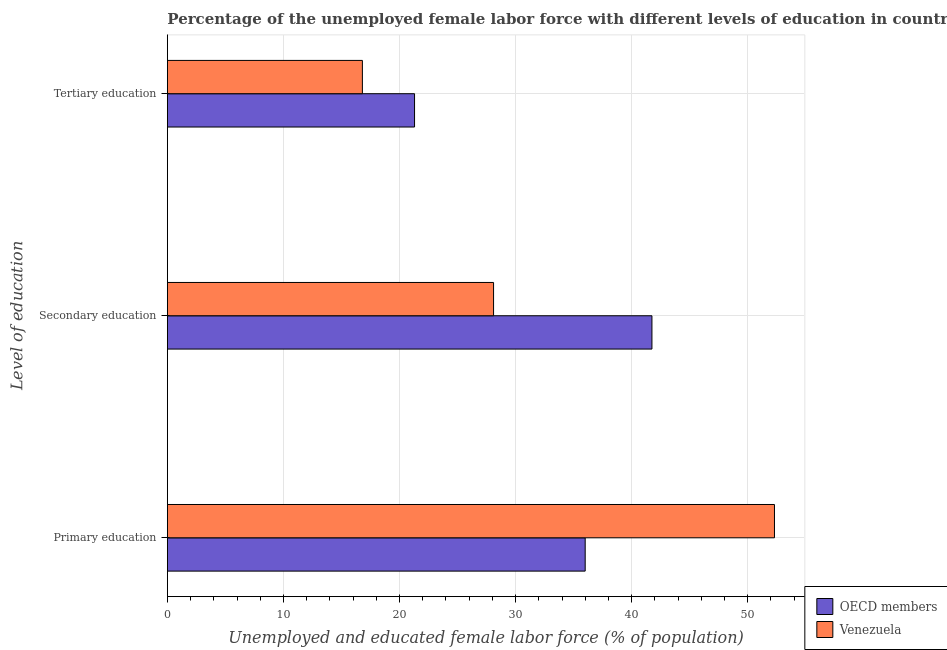How many different coloured bars are there?
Your answer should be very brief. 2. How many groups of bars are there?
Provide a short and direct response. 3. Are the number of bars per tick equal to the number of legend labels?
Ensure brevity in your answer.  Yes. What is the label of the 2nd group of bars from the top?
Provide a succinct answer. Secondary education. What is the percentage of female labor force who received secondary education in Venezuela?
Provide a succinct answer. 28.1. Across all countries, what is the maximum percentage of female labor force who received tertiary education?
Provide a short and direct response. 21.29. Across all countries, what is the minimum percentage of female labor force who received tertiary education?
Your answer should be very brief. 16.8. In which country was the percentage of female labor force who received primary education maximum?
Provide a short and direct response. Venezuela. In which country was the percentage of female labor force who received secondary education minimum?
Give a very brief answer. Venezuela. What is the total percentage of female labor force who received primary education in the graph?
Offer a very short reply. 88.29. What is the difference between the percentage of female labor force who received secondary education in OECD members and that in Venezuela?
Provide a succinct answer. 13.64. What is the difference between the percentage of female labor force who received secondary education in OECD members and the percentage of female labor force who received tertiary education in Venezuela?
Your answer should be compact. 24.94. What is the average percentage of female labor force who received tertiary education per country?
Provide a short and direct response. 19.05. What is the difference between the percentage of female labor force who received secondary education and percentage of female labor force who received tertiary education in OECD members?
Offer a very short reply. 20.45. In how many countries, is the percentage of female labor force who received primary education greater than 34 %?
Offer a terse response. 2. What is the ratio of the percentage of female labor force who received primary education in Venezuela to that in OECD members?
Ensure brevity in your answer.  1.45. Is the difference between the percentage of female labor force who received primary education in OECD members and Venezuela greater than the difference between the percentage of female labor force who received tertiary education in OECD members and Venezuela?
Ensure brevity in your answer.  No. What is the difference between the highest and the second highest percentage of female labor force who received tertiary education?
Your response must be concise. 4.49. What is the difference between the highest and the lowest percentage of female labor force who received primary education?
Keep it short and to the point. 16.31. What does the 1st bar from the top in Primary education represents?
Your answer should be very brief. Venezuela. What does the 2nd bar from the bottom in Tertiary education represents?
Provide a succinct answer. Venezuela. Are all the bars in the graph horizontal?
Make the answer very short. Yes. How many countries are there in the graph?
Offer a terse response. 2. What is the difference between two consecutive major ticks on the X-axis?
Keep it short and to the point. 10. Are the values on the major ticks of X-axis written in scientific E-notation?
Make the answer very short. No. What is the title of the graph?
Your answer should be very brief. Percentage of the unemployed female labor force with different levels of education in countries. Does "South Sudan" appear as one of the legend labels in the graph?
Keep it short and to the point. No. What is the label or title of the X-axis?
Your answer should be very brief. Unemployed and educated female labor force (% of population). What is the label or title of the Y-axis?
Ensure brevity in your answer.  Level of education. What is the Unemployed and educated female labor force (% of population) in OECD members in Primary education?
Offer a terse response. 35.99. What is the Unemployed and educated female labor force (% of population) in Venezuela in Primary education?
Keep it short and to the point. 52.3. What is the Unemployed and educated female labor force (% of population) of OECD members in Secondary education?
Offer a terse response. 41.74. What is the Unemployed and educated female labor force (% of population) in Venezuela in Secondary education?
Make the answer very short. 28.1. What is the Unemployed and educated female labor force (% of population) in OECD members in Tertiary education?
Provide a succinct answer. 21.29. What is the Unemployed and educated female labor force (% of population) of Venezuela in Tertiary education?
Make the answer very short. 16.8. Across all Level of education, what is the maximum Unemployed and educated female labor force (% of population) in OECD members?
Your response must be concise. 41.74. Across all Level of education, what is the maximum Unemployed and educated female labor force (% of population) in Venezuela?
Make the answer very short. 52.3. Across all Level of education, what is the minimum Unemployed and educated female labor force (% of population) of OECD members?
Your answer should be compact. 21.29. Across all Level of education, what is the minimum Unemployed and educated female labor force (% of population) in Venezuela?
Offer a very short reply. 16.8. What is the total Unemployed and educated female labor force (% of population) of OECD members in the graph?
Ensure brevity in your answer.  99.03. What is the total Unemployed and educated female labor force (% of population) of Venezuela in the graph?
Your answer should be very brief. 97.2. What is the difference between the Unemployed and educated female labor force (% of population) of OECD members in Primary education and that in Secondary education?
Your response must be concise. -5.75. What is the difference between the Unemployed and educated female labor force (% of population) in Venezuela in Primary education and that in Secondary education?
Your answer should be compact. 24.2. What is the difference between the Unemployed and educated female labor force (% of population) in OECD members in Primary education and that in Tertiary education?
Provide a succinct answer. 14.7. What is the difference between the Unemployed and educated female labor force (% of population) of Venezuela in Primary education and that in Tertiary education?
Your answer should be compact. 35.5. What is the difference between the Unemployed and educated female labor force (% of population) in OECD members in Secondary education and that in Tertiary education?
Keep it short and to the point. 20.45. What is the difference between the Unemployed and educated female labor force (% of population) of OECD members in Primary education and the Unemployed and educated female labor force (% of population) of Venezuela in Secondary education?
Ensure brevity in your answer.  7.89. What is the difference between the Unemployed and educated female labor force (% of population) in OECD members in Primary education and the Unemployed and educated female labor force (% of population) in Venezuela in Tertiary education?
Provide a succinct answer. 19.19. What is the difference between the Unemployed and educated female labor force (% of population) in OECD members in Secondary education and the Unemployed and educated female labor force (% of population) in Venezuela in Tertiary education?
Keep it short and to the point. 24.94. What is the average Unemployed and educated female labor force (% of population) in OECD members per Level of education?
Ensure brevity in your answer.  33.01. What is the average Unemployed and educated female labor force (% of population) in Venezuela per Level of education?
Give a very brief answer. 32.4. What is the difference between the Unemployed and educated female labor force (% of population) of OECD members and Unemployed and educated female labor force (% of population) of Venezuela in Primary education?
Your response must be concise. -16.31. What is the difference between the Unemployed and educated female labor force (% of population) in OECD members and Unemployed and educated female labor force (% of population) in Venezuela in Secondary education?
Ensure brevity in your answer.  13.64. What is the difference between the Unemployed and educated female labor force (% of population) in OECD members and Unemployed and educated female labor force (% of population) in Venezuela in Tertiary education?
Your answer should be compact. 4.49. What is the ratio of the Unemployed and educated female labor force (% of population) of OECD members in Primary education to that in Secondary education?
Your response must be concise. 0.86. What is the ratio of the Unemployed and educated female labor force (% of population) of Venezuela in Primary education to that in Secondary education?
Ensure brevity in your answer.  1.86. What is the ratio of the Unemployed and educated female labor force (% of population) of OECD members in Primary education to that in Tertiary education?
Provide a short and direct response. 1.69. What is the ratio of the Unemployed and educated female labor force (% of population) in Venezuela in Primary education to that in Tertiary education?
Provide a succinct answer. 3.11. What is the ratio of the Unemployed and educated female labor force (% of population) of OECD members in Secondary education to that in Tertiary education?
Your answer should be compact. 1.96. What is the ratio of the Unemployed and educated female labor force (% of population) of Venezuela in Secondary education to that in Tertiary education?
Provide a short and direct response. 1.67. What is the difference between the highest and the second highest Unemployed and educated female labor force (% of population) of OECD members?
Offer a very short reply. 5.75. What is the difference between the highest and the second highest Unemployed and educated female labor force (% of population) of Venezuela?
Give a very brief answer. 24.2. What is the difference between the highest and the lowest Unemployed and educated female labor force (% of population) in OECD members?
Your answer should be very brief. 20.45. What is the difference between the highest and the lowest Unemployed and educated female labor force (% of population) in Venezuela?
Make the answer very short. 35.5. 